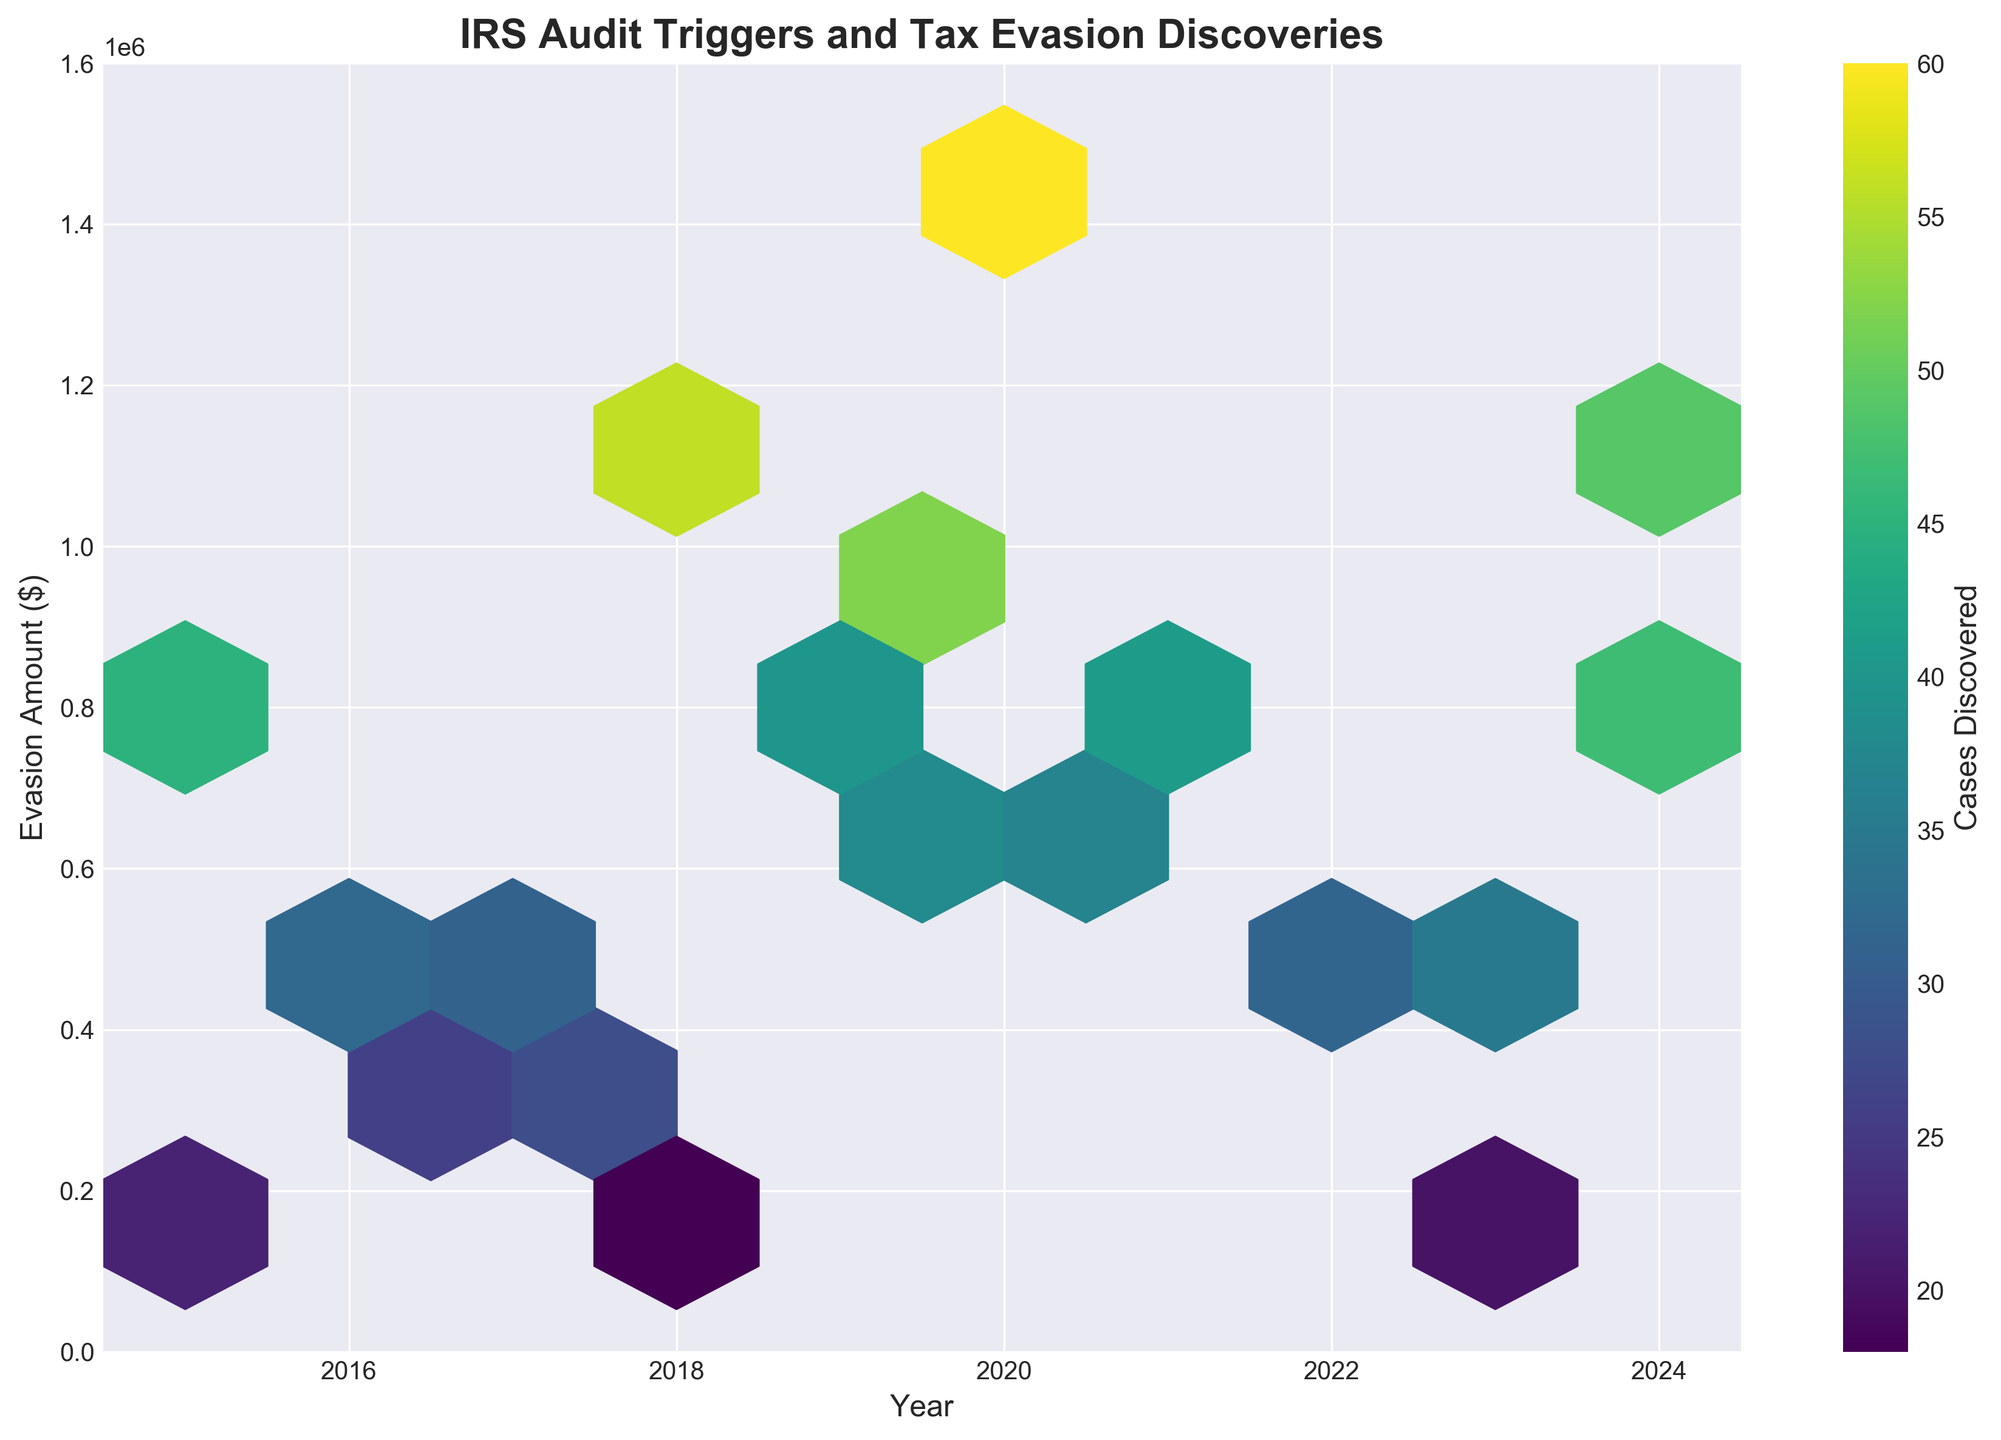What is the title of the plot? Look at the top of the plot where the title is usually placed. It states "IRS Audit Triggers and Tax Evasion Discoveries".
Answer: IRS Audit Triggers and Tax Evasion Discoveries What is the color of the hexagons in the plot? The color of the hexagons ranges from light yellow to dark green, indicating a gradient based on the number of cases discovered per hexagon.
Answer: Yellow to green Which year had the highest evasion amount? Look for the highest point on the y-axis labeled "Evasion Amount ($)", which occurs around 2020 with an evasion amount close to 1,500,000.
Answer: 2020 How many unique audit triggers are annotated? Count the number of annotations (yellow boxes with text and arrows) on the right side of the plot.
Answer: 20 In which year were the highest number of cases discovered associated with estate tax returns? Locate the hexagon corresponding to 2020 on the plot and note the color it is shaded, which is dark green, indicating the highest number of cases.
Answer: 2020 Compare the evasion amounts of "Offshore Accounts" and "Cryptocurrency Transactions" for the years they appear. Which one is higher? Find "Offshore Accounts" in 2018 and "Cryptocurrency Transactions" in 2021. Offshore Accounts have an evasion amount around 1,200,000, which is higher than Cryptocurrency Transactions around 800,000.
Answer: Offshore Accounts What is the general trend in the number of cases discovered from 2015 to 2024? Track the color intensity of the hexagons from 2015 to 2024. Generally, the color darkens over time, indicating an increasing trend in the number of cases discovered.
Answer: Increasing Which audit trigger had the lowest amount of tax evasion in the period from 2015 to 2024? Identify the trigger with the lowest point on the y-axis. "Earned Income Tax Credit" in 2023 has the lowest evasion amount at around 150,000.
Answer: Earned Income Tax Credit Are high-income earners more likely to have higher evasion amounts compared to rental property losses? Compare the color intensities and heights on the y-axis for "High-Income Earners" in 2020 and "Rental Property Losses" in 2022. High-Income Earners have both higher evasion amounts and darker color (more cases).
Answer: Yes What is the color coding scheme used to indicate the number of cases discovered? Check the color bar next to the plot, which shows a gradient from lighter to darker colors representing increasing numbers of cases.
Answer: Light yellow to dark green 